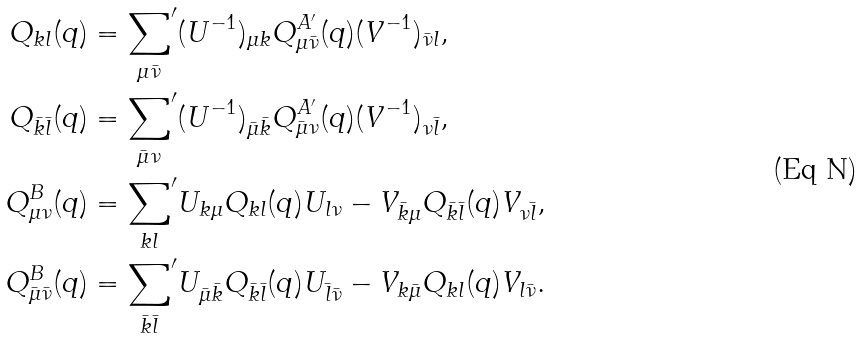<formula> <loc_0><loc_0><loc_500><loc_500>Q _ { k l } ( q ) & = { \sum _ { \mu \bar { \nu } } } ^ { \prime } ( U ^ { - 1 } ) _ { \mu k } Q ^ { A ^ { \prime } } _ { \mu \bar { \nu } } ( q ) ( V ^ { - 1 } ) _ { \bar { \nu } l } , \\ Q _ { \bar { k } \bar { l } } ( q ) & = { \sum _ { \bar { \mu } \nu } } ^ { \prime } ( U ^ { - 1 } ) _ { \bar { \mu } \bar { k } } Q ^ { A ^ { \prime } } _ { \bar { \mu } \nu } ( q ) ( V ^ { - 1 } ) _ { \nu \bar { l } } , \\ Q ^ { B } _ { \mu \nu } ( q ) & = { { \sum _ { k l } } } ^ { \prime } U _ { k \mu } Q _ { k l } ( q ) U _ { l \nu } - V _ { \bar { k } \mu } Q _ { \bar { k } \bar { l } } ( q ) V _ { \nu \bar { l } } , \\ Q ^ { B } _ { \bar { \mu } \bar { \nu } } ( q ) & = { \sum _ { \bar { k } \bar { l } } } ^ { \prime } U _ { \bar { \mu } \bar { k } } Q _ { \bar { k } \bar { l } } ( q ) U _ { \bar { l } \bar { \nu } } - V _ { k \bar { \mu } } Q _ { k l } ( q ) V _ { l \bar { \nu } } .</formula> 